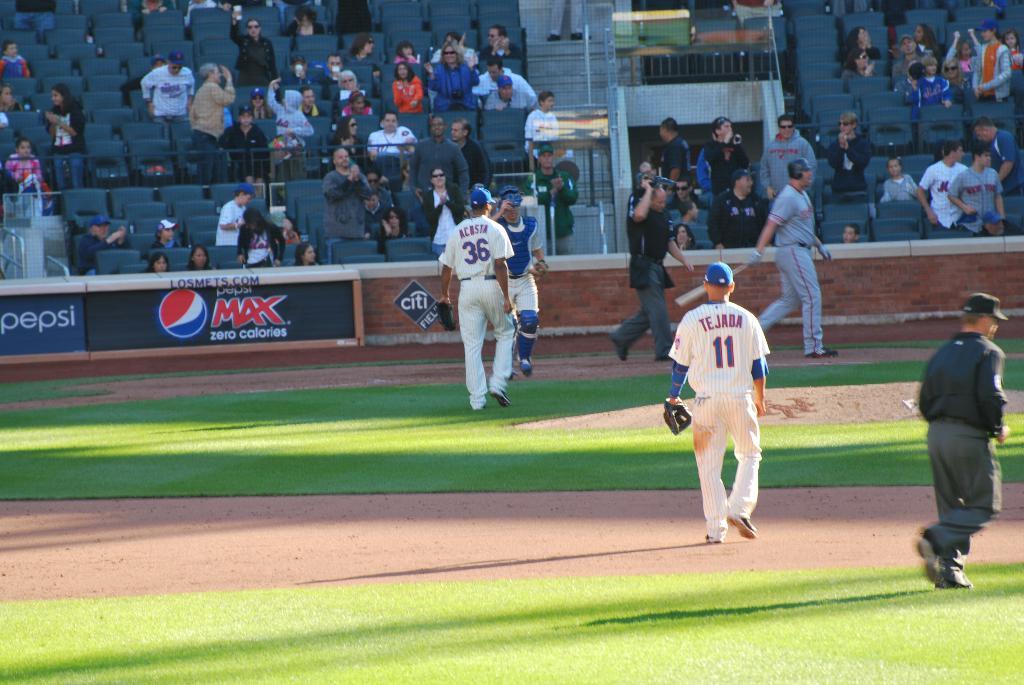How many players are on the field?
Offer a terse response. Answering does not require reading text in the image. 